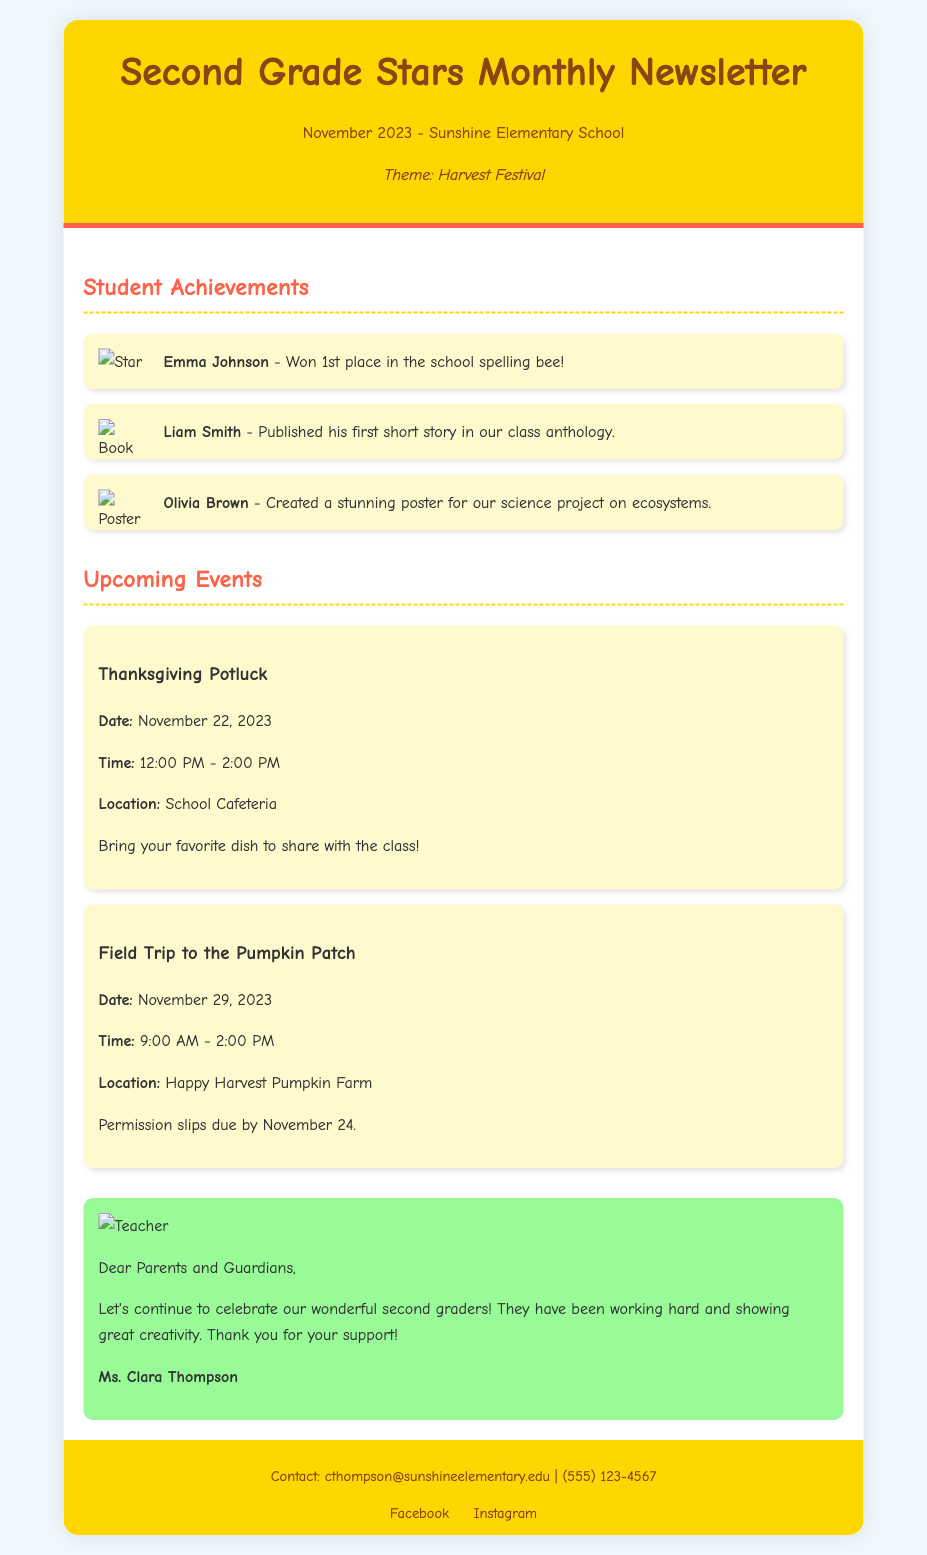What theme is highlighted in the newsletter? The newsletter features a theme that relates to a specific seasonal event, which is indicated in the header.
Answer: Harvest Festival Who won 1st place in the school spelling bee? This achievement is mentioned in the "Student Achievements" section and identifies a specific student.
Answer: Emma Johnson What date is the Thanksgiving Potluck scheduled for? The date is clearly stated in the "Upcoming Events" section of the newsletter.
Answer: November 22, 2023 What is the location for the field trip to the pumpkin patch? This information is provided in the details of the upcoming event section.
Answer: Happy Harvest Pumpkin Farm Who published their first short story in the class anthology? This achievement mentions a specific student recognized for their writing.
Answer: Liam Smith How long is the Field Trip to the Pumpkin Patch planned to last? The duration of the event is specified in the schedule section of the upcoming events.
Answer: 5 hours What is the contact email for Ms. Clara Thompson? The contact information is found in the footer of the newsletter.
Answer: cthompson@sunshineelementary.edu What color is the background of the newsletter? The visual design of the document includes a description of the background color used.
Answer: Light blue What is the teacher's note about? This section summarizes the content of the teacher's note in the newsletter.
Answer: Celebrating student efforts 